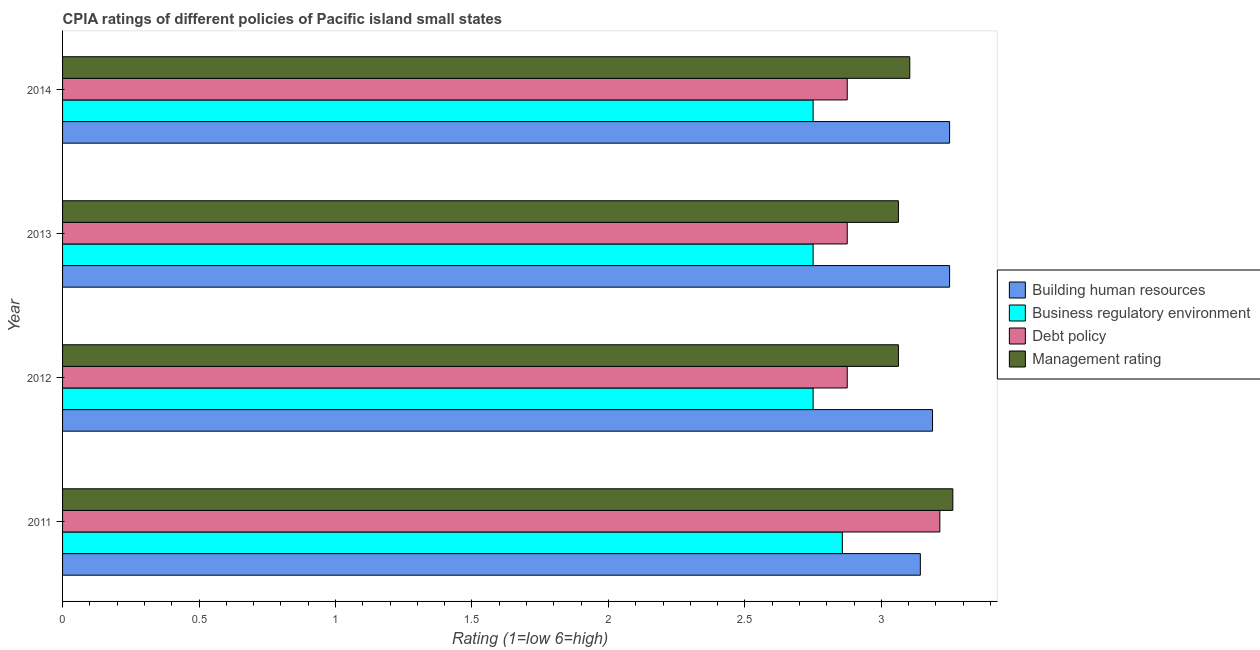How many different coloured bars are there?
Make the answer very short. 4. How many groups of bars are there?
Give a very brief answer. 4. Are the number of bars per tick equal to the number of legend labels?
Ensure brevity in your answer.  Yes. Are the number of bars on each tick of the Y-axis equal?
Your answer should be very brief. Yes. How many bars are there on the 4th tick from the top?
Offer a terse response. 4. How many bars are there on the 1st tick from the bottom?
Make the answer very short. 4. What is the cpia rating of debt policy in 2012?
Provide a short and direct response. 2.88. Across all years, what is the maximum cpia rating of management?
Your answer should be very brief. 3.26. Across all years, what is the minimum cpia rating of management?
Your response must be concise. 3.06. In which year was the cpia rating of building human resources maximum?
Your answer should be compact. 2013. What is the total cpia rating of debt policy in the graph?
Provide a succinct answer. 11.84. What is the difference between the cpia rating of building human resources in 2012 and that in 2013?
Your answer should be compact. -0.06. What is the difference between the cpia rating of debt policy in 2014 and the cpia rating of building human resources in 2011?
Your response must be concise. -0.27. What is the average cpia rating of management per year?
Make the answer very short. 3.12. In the year 2011, what is the difference between the cpia rating of building human resources and cpia rating of business regulatory environment?
Give a very brief answer. 0.29. In how many years, is the cpia rating of debt policy greater than 1.5 ?
Give a very brief answer. 4. What is the ratio of the cpia rating of management in 2011 to that in 2012?
Offer a terse response. 1.06. Is the difference between the cpia rating of management in 2013 and 2014 greater than the difference between the cpia rating of debt policy in 2013 and 2014?
Ensure brevity in your answer.  No. What is the difference between the highest and the second highest cpia rating of management?
Make the answer very short. 0.16. What is the difference between the highest and the lowest cpia rating of management?
Your answer should be compact. 0.2. Is it the case that in every year, the sum of the cpia rating of business regulatory environment and cpia rating of debt policy is greater than the sum of cpia rating of building human resources and cpia rating of management?
Give a very brief answer. No. What does the 2nd bar from the top in 2012 represents?
Offer a terse response. Debt policy. What does the 2nd bar from the bottom in 2013 represents?
Your response must be concise. Business regulatory environment. How many bars are there?
Keep it short and to the point. 16. Are all the bars in the graph horizontal?
Your answer should be compact. Yes. How many years are there in the graph?
Make the answer very short. 4. What is the difference between two consecutive major ticks on the X-axis?
Give a very brief answer. 0.5. Does the graph contain any zero values?
Your answer should be very brief. No. How many legend labels are there?
Ensure brevity in your answer.  4. What is the title of the graph?
Your response must be concise. CPIA ratings of different policies of Pacific island small states. Does "Quality of public administration" appear as one of the legend labels in the graph?
Your response must be concise. No. What is the Rating (1=low 6=high) in Building human resources in 2011?
Your response must be concise. 3.14. What is the Rating (1=low 6=high) of Business regulatory environment in 2011?
Make the answer very short. 2.86. What is the Rating (1=low 6=high) of Debt policy in 2011?
Your response must be concise. 3.21. What is the Rating (1=low 6=high) in Management rating in 2011?
Give a very brief answer. 3.26. What is the Rating (1=low 6=high) in Building human resources in 2012?
Offer a terse response. 3.19. What is the Rating (1=low 6=high) of Business regulatory environment in 2012?
Provide a short and direct response. 2.75. What is the Rating (1=low 6=high) in Debt policy in 2012?
Ensure brevity in your answer.  2.88. What is the Rating (1=low 6=high) in Management rating in 2012?
Your answer should be compact. 3.06. What is the Rating (1=low 6=high) of Business regulatory environment in 2013?
Provide a succinct answer. 2.75. What is the Rating (1=low 6=high) of Debt policy in 2013?
Ensure brevity in your answer.  2.88. What is the Rating (1=low 6=high) in Management rating in 2013?
Your answer should be compact. 3.06. What is the Rating (1=low 6=high) in Business regulatory environment in 2014?
Provide a short and direct response. 2.75. What is the Rating (1=low 6=high) of Debt policy in 2014?
Keep it short and to the point. 2.88. What is the Rating (1=low 6=high) of Management rating in 2014?
Your response must be concise. 3.1. Across all years, what is the maximum Rating (1=low 6=high) of Business regulatory environment?
Your answer should be very brief. 2.86. Across all years, what is the maximum Rating (1=low 6=high) of Debt policy?
Give a very brief answer. 3.21. Across all years, what is the maximum Rating (1=low 6=high) of Management rating?
Ensure brevity in your answer.  3.26. Across all years, what is the minimum Rating (1=low 6=high) of Building human resources?
Ensure brevity in your answer.  3.14. Across all years, what is the minimum Rating (1=low 6=high) in Business regulatory environment?
Your answer should be very brief. 2.75. Across all years, what is the minimum Rating (1=low 6=high) in Debt policy?
Ensure brevity in your answer.  2.88. Across all years, what is the minimum Rating (1=low 6=high) in Management rating?
Your answer should be very brief. 3.06. What is the total Rating (1=low 6=high) in Building human resources in the graph?
Give a very brief answer. 12.83. What is the total Rating (1=low 6=high) in Business regulatory environment in the graph?
Offer a terse response. 11.11. What is the total Rating (1=low 6=high) of Debt policy in the graph?
Your response must be concise. 11.84. What is the total Rating (1=low 6=high) in Management rating in the graph?
Your answer should be very brief. 12.49. What is the difference between the Rating (1=low 6=high) in Building human resources in 2011 and that in 2012?
Provide a succinct answer. -0.04. What is the difference between the Rating (1=low 6=high) of Business regulatory environment in 2011 and that in 2012?
Offer a very short reply. 0.11. What is the difference between the Rating (1=low 6=high) of Debt policy in 2011 and that in 2012?
Keep it short and to the point. 0.34. What is the difference between the Rating (1=low 6=high) of Management rating in 2011 and that in 2012?
Your response must be concise. 0.2. What is the difference between the Rating (1=low 6=high) of Building human resources in 2011 and that in 2013?
Your answer should be compact. -0.11. What is the difference between the Rating (1=low 6=high) in Business regulatory environment in 2011 and that in 2013?
Give a very brief answer. 0.11. What is the difference between the Rating (1=low 6=high) of Debt policy in 2011 and that in 2013?
Make the answer very short. 0.34. What is the difference between the Rating (1=low 6=high) in Management rating in 2011 and that in 2013?
Provide a short and direct response. 0.2. What is the difference between the Rating (1=low 6=high) of Building human resources in 2011 and that in 2014?
Offer a very short reply. -0.11. What is the difference between the Rating (1=low 6=high) of Business regulatory environment in 2011 and that in 2014?
Keep it short and to the point. 0.11. What is the difference between the Rating (1=low 6=high) in Debt policy in 2011 and that in 2014?
Give a very brief answer. 0.34. What is the difference between the Rating (1=low 6=high) in Management rating in 2011 and that in 2014?
Your answer should be very brief. 0.16. What is the difference between the Rating (1=low 6=high) of Building human resources in 2012 and that in 2013?
Keep it short and to the point. -0.06. What is the difference between the Rating (1=low 6=high) in Debt policy in 2012 and that in 2013?
Offer a very short reply. 0. What is the difference between the Rating (1=low 6=high) of Management rating in 2012 and that in 2013?
Give a very brief answer. 0. What is the difference between the Rating (1=low 6=high) in Building human resources in 2012 and that in 2014?
Provide a succinct answer. -0.06. What is the difference between the Rating (1=low 6=high) of Management rating in 2012 and that in 2014?
Offer a very short reply. -0.04. What is the difference between the Rating (1=low 6=high) in Business regulatory environment in 2013 and that in 2014?
Provide a short and direct response. 0. What is the difference between the Rating (1=low 6=high) in Debt policy in 2013 and that in 2014?
Make the answer very short. 0. What is the difference between the Rating (1=low 6=high) of Management rating in 2013 and that in 2014?
Give a very brief answer. -0.04. What is the difference between the Rating (1=low 6=high) in Building human resources in 2011 and the Rating (1=low 6=high) in Business regulatory environment in 2012?
Make the answer very short. 0.39. What is the difference between the Rating (1=low 6=high) of Building human resources in 2011 and the Rating (1=low 6=high) of Debt policy in 2012?
Offer a terse response. 0.27. What is the difference between the Rating (1=low 6=high) in Building human resources in 2011 and the Rating (1=low 6=high) in Management rating in 2012?
Provide a short and direct response. 0.08. What is the difference between the Rating (1=low 6=high) of Business regulatory environment in 2011 and the Rating (1=low 6=high) of Debt policy in 2012?
Your response must be concise. -0.02. What is the difference between the Rating (1=low 6=high) of Business regulatory environment in 2011 and the Rating (1=low 6=high) of Management rating in 2012?
Offer a terse response. -0.21. What is the difference between the Rating (1=low 6=high) of Debt policy in 2011 and the Rating (1=low 6=high) of Management rating in 2012?
Offer a terse response. 0.15. What is the difference between the Rating (1=low 6=high) of Building human resources in 2011 and the Rating (1=low 6=high) of Business regulatory environment in 2013?
Provide a succinct answer. 0.39. What is the difference between the Rating (1=low 6=high) in Building human resources in 2011 and the Rating (1=low 6=high) in Debt policy in 2013?
Give a very brief answer. 0.27. What is the difference between the Rating (1=low 6=high) of Building human resources in 2011 and the Rating (1=low 6=high) of Management rating in 2013?
Offer a terse response. 0.08. What is the difference between the Rating (1=low 6=high) of Business regulatory environment in 2011 and the Rating (1=low 6=high) of Debt policy in 2013?
Your answer should be compact. -0.02. What is the difference between the Rating (1=low 6=high) of Business regulatory environment in 2011 and the Rating (1=low 6=high) of Management rating in 2013?
Offer a very short reply. -0.21. What is the difference between the Rating (1=low 6=high) of Debt policy in 2011 and the Rating (1=low 6=high) of Management rating in 2013?
Offer a terse response. 0.15. What is the difference between the Rating (1=low 6=high) in Building human resources in 2011 and the Rating (1=low 6=high) in Business regulatory environment in 2014?
Make the answer very short. 0.39. What is the difference between the Rating (1=low 6=high) in Building human resources in 2011 and the Rating (1=low 6=high) in Debt policy in 2014?
Your answer should be compact. 0.27. What is the difference between the Rating (1=low 6=high) in Building human resources in 2011 and the Rating (1=low 6=high) in Management rating in 2014?
Provide a succinct answer. 0.04. What is the difference between the Rating (1=low 6=high) in Business regulatory environment in 2011 and the Rating (1=low 6=high) in Debt policy in 2014?
Offer a terse response. -0.02. What is the difference between the Rating (1=low 6=high) in Business regulatory environment in 2011 and the Rating (1=low 6=high) in Management rating in 2014?
Your response must be concise. -0.25. What is the difference between the Rating (1=low 6=high) in Debt policy in 2011 and the Rating (1=low 6=high) in Management rating in 2014?
Your response must be concise. 0.11. What is the difference between the Rating (1=low 6=high) in Building human resources in 2012 and the Rating (1=low 6=high) in Business regulatory environment in 2013?
Provide a succinct answer. 0.44. What is the difference between the Rating (1=low 6=high) in Building human resources in 2012 and the Rating (1=low 6=high) in Debt policy in 2013?
Provide a succinct answer. 0.31. What is the difference between the Rating (1=low 6=high) of Business regulatory environment in 2012 and the Rating (1=low 6=high) of Debt policy in 2013?
Keep it short and to the point. -0.12. What is the difference between the Rating (1=low 6=high) in Business regulatory environment in 2012 and the Rating (1=low 6=high) in Management rating in 2013?
Keep it short and to the point. -0.31. What is the difference between the Rating (1=low 6=high) in Debt policy in 2012 and the Rating (1=low 6=high) in Management rating in 2013?
Offer a terse response. -0.19. What is the difference between the Rating (1=low 6=high) in Building human resources in 2012 and the Rating (1=low 6=high) in Business regulatory environment in 2014?
Ensure brevity in your answer.  0.44. What is the difference between the Rating (1=low 6=high) of Building human resources in 2012 and the Rating (1=low 6=high) of Debt policy in 2014?
Offer a very short reply. 0.31. What is the difference between the Rating (1=low 6=high) of Building human resources in 2012 and the Rating (1=low 6=high) of Management rating in 2014?
Your answer should be compact. 0.08. What is the difference between the Rating (1=low 6=high) in Business regulatory environment in 2012 and the Rating (1=low 6=high) in Debt policy in 2014?
Ensure brevity in your answer.  -0.12. What is the difference between the Rating (1=low 6=high) in Business regulatory environment in 2012 and the Rating (1=low 6=high) in Management rating in 2014?
Keep it short and to the point. -0.35. What is the difference between the Rating (1=low 6=high) in Debt policy in 2012 and the Rating (1=low 6=high) in Management rating in 2014?
Ensure brevity in your answer.  -0.23. What is the difference between the Rating (1=low 6=high) in Building human resources in 2013 and the Rating (1=low 6=high) in Debt policy in 2014?
Give a very brief answer. 0.38. What is the difference between the Rating (1=low 6=high) of Building human resources in 2013 and the Rating (1=low 6=high) of Management rating in 2014?
Your answer should be compact. 0.15. What is the difference between the Rating (1=low 6=high) in Business regulatory environment in 2013 and the Rating (1=low 6=high) in Debt policy in 2014?
Your answer should be compact. -0.12. What is the difference between the Rating (1=low 6=high) in Business regulatory environment in 2013 and the Rating (1=low 6=high) in Management rating in 2014?
Provide a succinct answer. -0.35. What is the difference between the Rating (1=low 6=high) in Debt policy in 2013 and the Rating (1=low 6=high) in Management rating in 2014?
Ensure brevity in your answer.  -0.23. What is the average Rating (1=low 6=high) of Building human resources per year?
Keep it short and to the point. 3.21. What is the average Rating (1=low 6=high) of Business regulatory environment per year?
Give a very brief answer. 2.78. What is the average Rating (1=low 6=high) in Debt policy per year?
Your answer should be very brief. 2.96. What is the average Rating (1=low 6=high) in Management rating per year?
Offer a very short reply. 3.12. In the year 2011, what is the difference between the Rating (1=low 6=high) in Building human resources and Rating (1=low 6=high) in Business regulatory environment?
Provide a succinct answer. 0.29. In the year 2011, what is the difference between the Rating (1=low 6=high) of Building human resources and Rating (1=low 6=high) of Debt policy?
Give a very brief answer. -0.07. In the year 2011, what is the difference between the Rating (1=low 6=high) in Building human resources and Rating (1=low 6=high) in Management rating?
Ensure brevity in your answer.  -0.12. In the year 2011, what is the difference between the Rating (1=low 6=high) of Business regulatory environment and Rating (1=low 6=high) of Debt policy?
Give a very brief answer. -0.36. In the year 2011, what is the difference between the Rating (1=low 6=high) of Business regulatory environment and Rating (1=low 6=high) of Management rating?
Your answer should be compact. -0.4. In the year 2011, what is the difference between the Rating (1=low 6=high) of Debt policy and Rating (1=low 6=high) of Management rating?
Keep it short and to the point. -0.05. In the year 2012, what is the difference between the Rating (1=low 6=high) of Building human resources and Rating (1=low 6=high) of Business regulatory environment?
Your answer should be compact. 0.44. In the year 2012, what is the difference between the Rating (1=low 6=high) of Building human resources and Rating (1=low 6=high) of Debt policy?
Your answer should be compact. 0.31. In the year 2012, what is the difference between the Rating (1=low 6=high) in Business regulatory environment and Rating (1=low 6=high) in Debt policy?
Provide a short and direct response. -0.12. In the year 2012, what is the difference between the Rating (1=low 6=high) in Business regulatory environment and Rating (1=low 6=high) in Management rating?
Give a very brief answer. -0.31. In the year 2012, what is the difference between the Rating (1=low 6=high) of Debt policy and Rating (1=low 6=high) of Management rating?
Ensure brevity in your answer.  -0.19. In the year 2013, what is the difference between the Rating (1=low 6=high) of Building human resources and Rating (1=low 6=high) of Management rating?
Provide a succinct answer. 0.19. In the year 2013, what is the difference between the Rating (1=low 6=high) of Business regulatory environment and Rating (1=low 6=high) of Debt policy?
Make the answer very short. -0.12. In the year 2013, what is the difference between the Rating (1=low 6=high) in Business regulatory environment and Rating (1=low 6=high) in Management rating?
Offer a very short reply. -0.31. In the year 2013, what is the difference between the Rating (1=low 6=high) in Debt policy and Rating (1=low 6=high) in Management rating?
Ensure brevity in your answer.  -0.19. In the year 2014, what is the difference between the Rating (1=low 6=high) in Building human resources and Rating (1=low 6=high) in Debt policy?
Provide a short and direct response. 0.38. In the year 2014, what is the difference between the Rating (1=low 6=high) of Building human resources and Rating (1=low 6=high) of Management rating?
Your answer should be very brief. 0.15. In the year 2014, what is the difference between the Rating (1=low 6=high) of Business regulatory environment and Rating (1=low 6=high) of Debt policy?
Your response must be concise. -0.12. In the year 2014, what is the difference between the Rating (1=low 6=high) in Business regulatory environment and Rating (1=low 6=high) in Management rating?
Keep it short and to the point. -0.35. In the year 2014, what is the difference between the Rating (1=low 6=high) in Debt policy and Rating (1=low 6=high) in Management rating?
Your response must be concise. -0.23. What is the ratio of the Rating (1=low 6=high) in Business regulatory environment in 2011 to that in 2012?
Provide a short and direct response. 1.04. What is the ratio of the Rating (1=low 6=high) of Debt policy in 2011 to that in 2012?
Keep it short and to the point. 1.12. What is the ratio of the Rating (1=low 6=high) of Management rating in 2011 to that in 2012?
Make the answer very short. 1.07. What is the ratio of the Rating (1=low 6=high) in Building human resources in 2011 to that in 2013?
Make the answer very short. 0.97. What is the ratio of the Rating (1=low 6=high) of Business regulatory environment in 2011 to that in 2013?
Ensure brevity in your answer.  1.04. What is the ratio of the Rating (1=low 6=high) in Debt policy in 2011 to that in 2013?
Make the answer very short. 1.12. What is the ratio of the Rating (1=low 6=high) in Management rating in 2011 to that in 2013?
Offer a terse response. 1.07. What is the ratio of the Rating (1=low 6=high) of Business regulatory environment in 2011 to that in 2014?
Offer a terse response. 1.04. What is the ratio of the Rating (1=low 6=high) of Debt policy in 2011 to that in 2014?
Keep it short and to the point. 1.12. What is the ratio of the Rating (1=low 6=high) in Management rating in 2011 to that in 2014?
Make the answer very short. 1.05. What is the ratio of the Rating (1=low 6=high) in Building human resources in 2012 to that in 2013?
Provide a short and direct response. 0.98. What is the ratio of the Rating (1=low 6=high) in Debt policy in 2012 to that in 2013?
Offer a terse response. 1. What is the ratio of the Rating (1=low 6=high) in Management rating in 2012 to that in 2013?
Your answer should be compact. 1. What is the ratio of the Rating (1=low 6=high) in Building human resources in 2012 to that in 2014?
Provide a succinct answer. 0.98. What is the ratio of the Rating (1=low 6=high) of Management rating in 2012 to that in 2014?
Your response must be concise. 0.99. What is the ratio of the Rating (1=low 6=high) of Business regulatory environment in 2013 to that in 2014?
Provide a succinct answer. 1. What is the ratio of the Rating (1=low 6=high) in Management rating in 2013 to that in 2014?
Your response must be concise. 0.99. What is the difference between the highest and the second highest Rating (1=low 6=high) in Business regulatory environment?
Ensure brevity in your answer.  0.11. What is the difference between the highest and the second highest Rating (1=low 6=high) of Debt policy?
Give a very brief answer. 0.34. What is the difference between the highest and the second highest Rating (1=low 6=high) in Management rating?
Keep it short and to the point. 0.16. What is the difference between the highest and the lowest Rating (1=low 6=high) in Building human resources?
Ensure brevity in your answer.  0.11. What is the difference between the highest and the lowest Rating (1=low 6=high) of Business regulatory environment?
Your response must be concise. 0.11. What is the difference between the highest and the lowest Rating (1=low 6=high) in Debt policy?
Your answer should be compact. 0.34. What is the difference between the highest and the lowest Rating (1=low 6=high) of Management rating?
Your answer should be very brief. 0.2. 